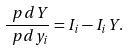Convert formula to latex. <formula><loc_0><loc_0><loc_500><loc_500>\frac { \ p d Y } { \ p d y _ { i } } = I _ { i } - I _ { i } Y .</formula> 